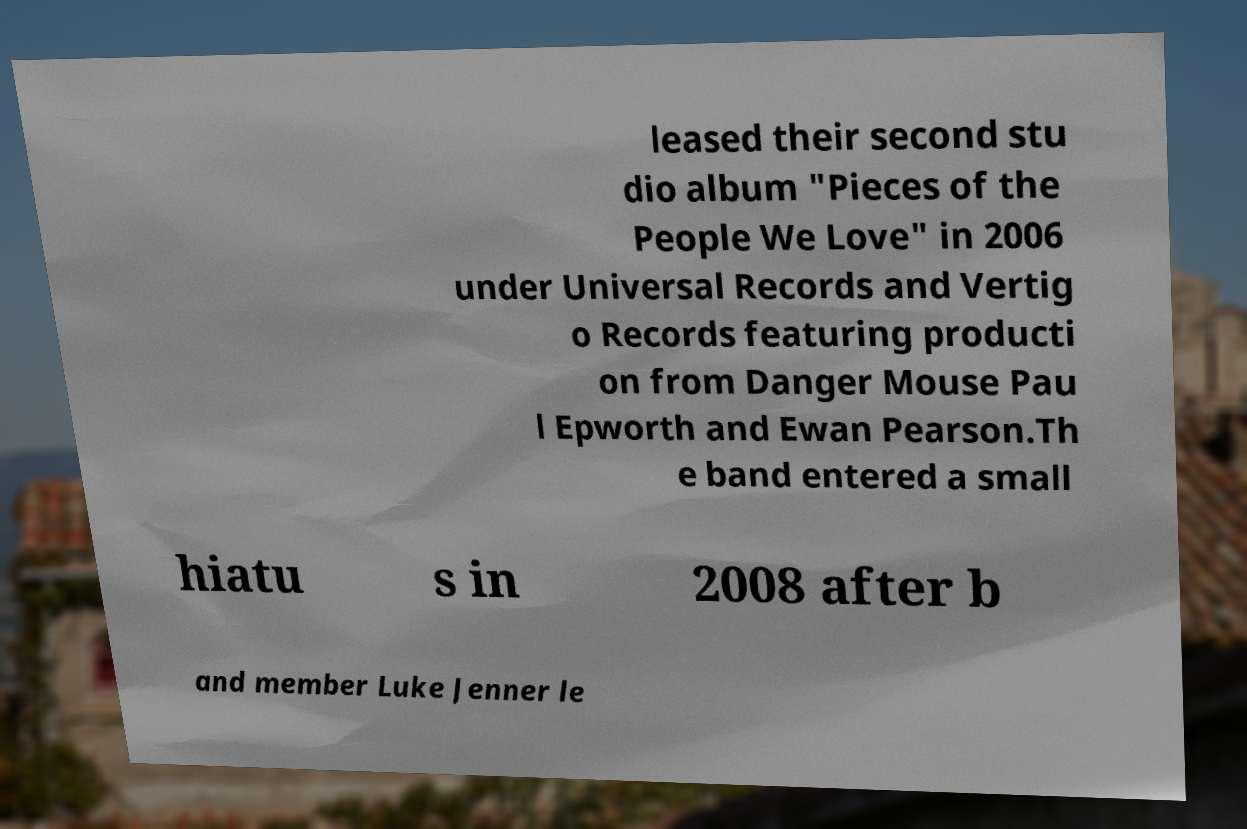I need the written content from this picture converted into text. Can you do that? leased their second stu dio album "Pieces of the People We Love" in 2006 under Universal Records and Vertig o Records featuring producti on from Danger Mouse Pau l Epworth and Ewan Pearson.Th e band entered a small hiatu s in 2008 after b and member Luke Jenner le 